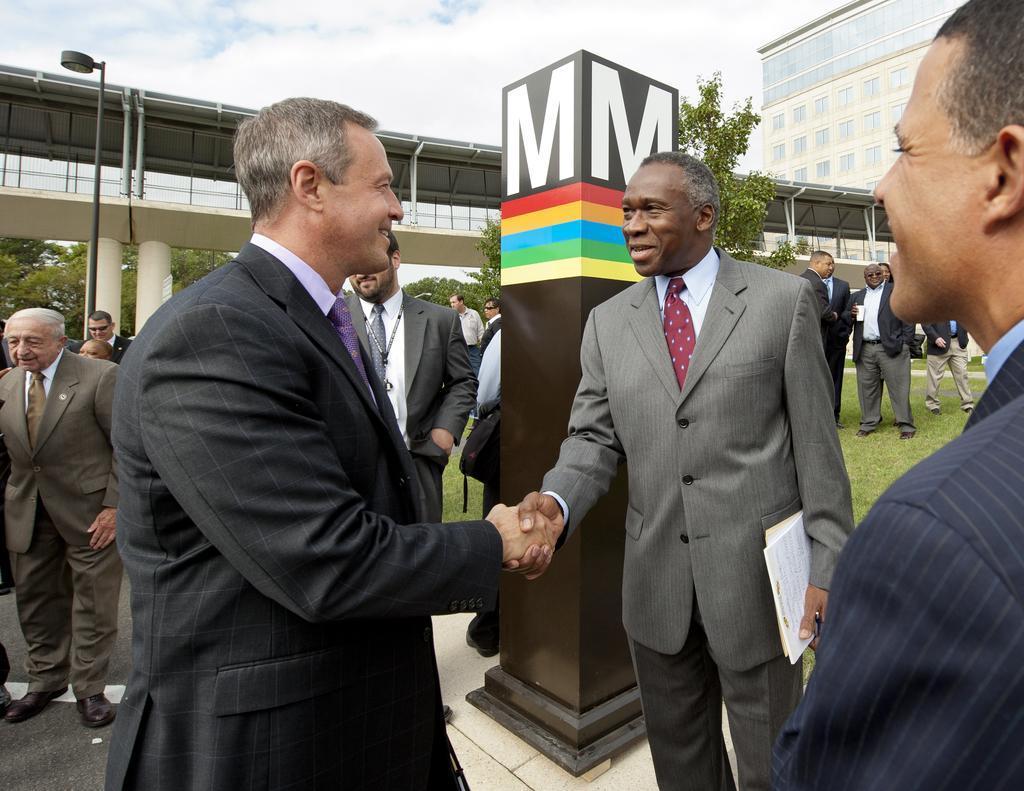Describe this image in one or two sentences. In this picture there are men in the center of the image and there is a pillar behind them and there are other people in the background area of the image, on the grassland and there is a building, bridge, and trees in the background area of the image and there is a pole on the left side of the image. 